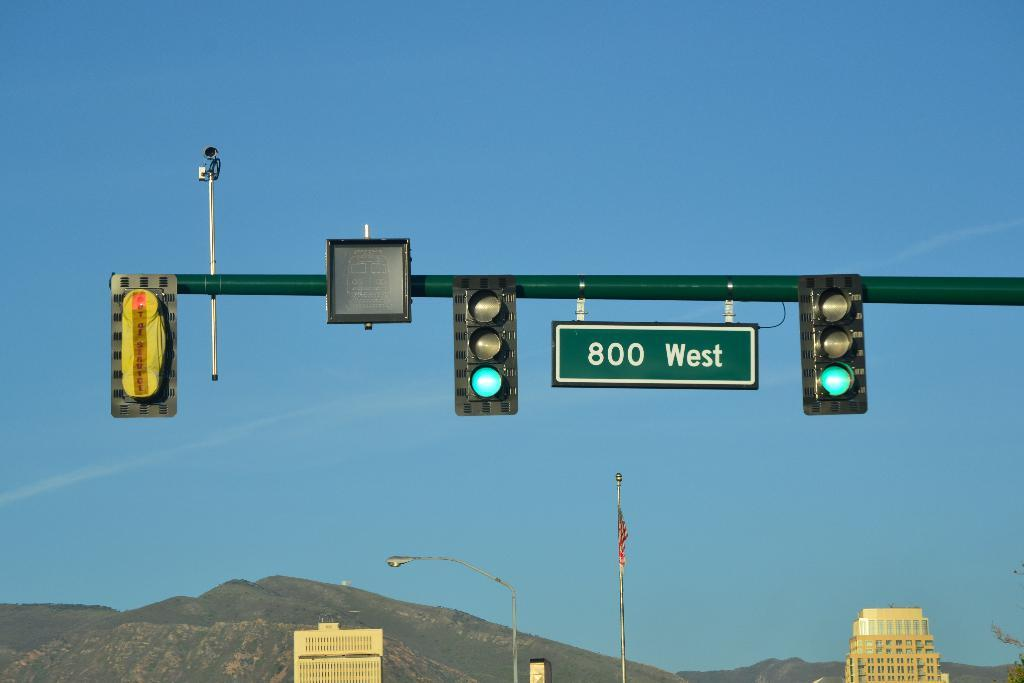What type of signaling devices can be seen in the image? There are traffic signals in the image. What other objects are present in the image besides the traffic signals? There are boards, poles, a flag, buildings, and other objects in the image. What is the background of the image? There is a mountain and sky visible in the background of the image. Can you tell me how many sheep are grazing on the farm in the image? There is no farm or sheep present in the image. What type of health advice is being given on the boards in the image? There is no health advice or boards related to health in the image. 